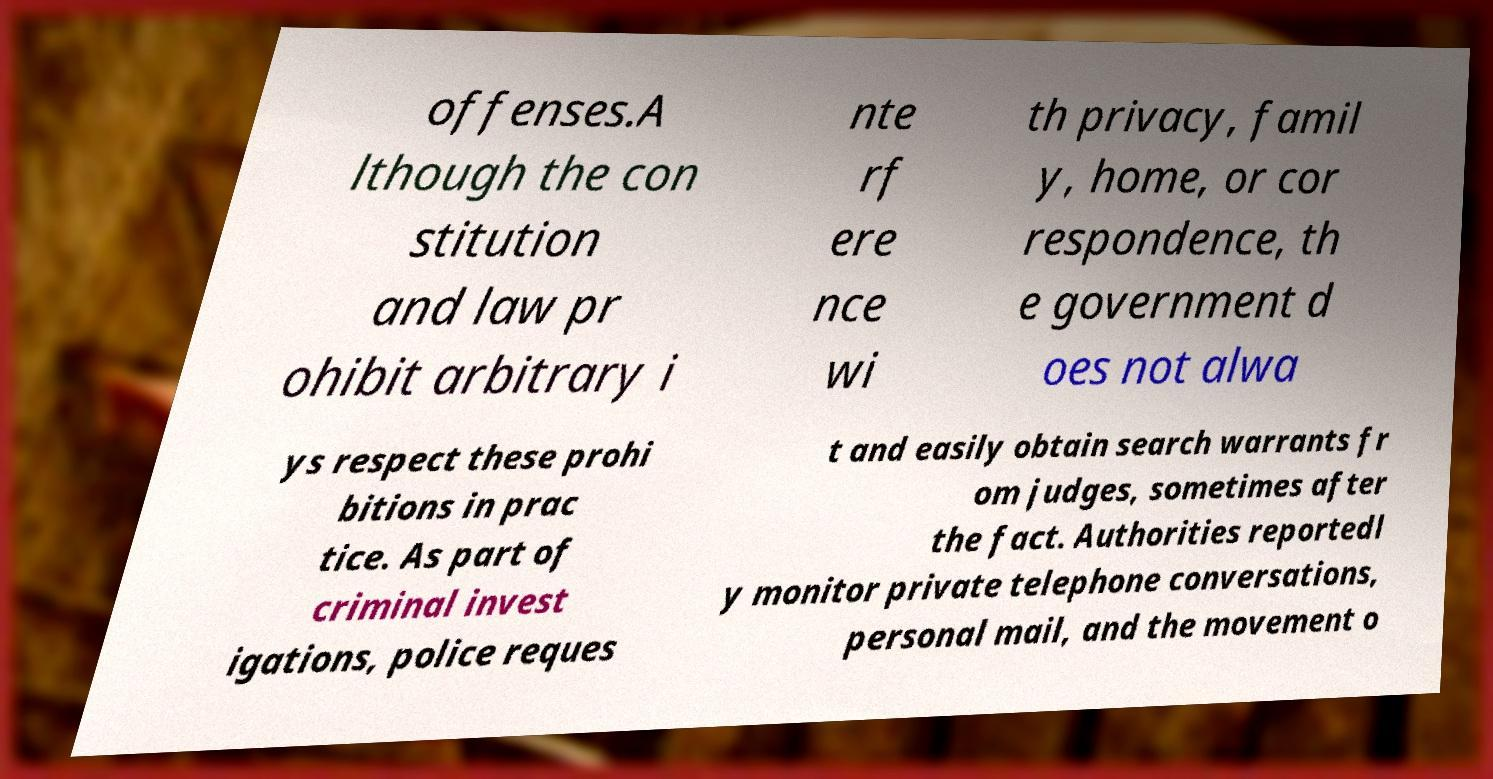For documentation purposes, I need the text within this image transcribed. Could you provide that? offenses.A lthough the con stitution and law pr ohibit arbitrary i nte rf ere nce wi th privacy, famil y, home, or cor respondence, th e government d oes not alwa ys respect these prohi bitions in prac tice. As part of criminal invest igations, police reques t and easily obtain search warrants fr om judges, sometimes after the fact. Authorities reportedl y monitor private telephone conversations, personal mail, and the movement o 